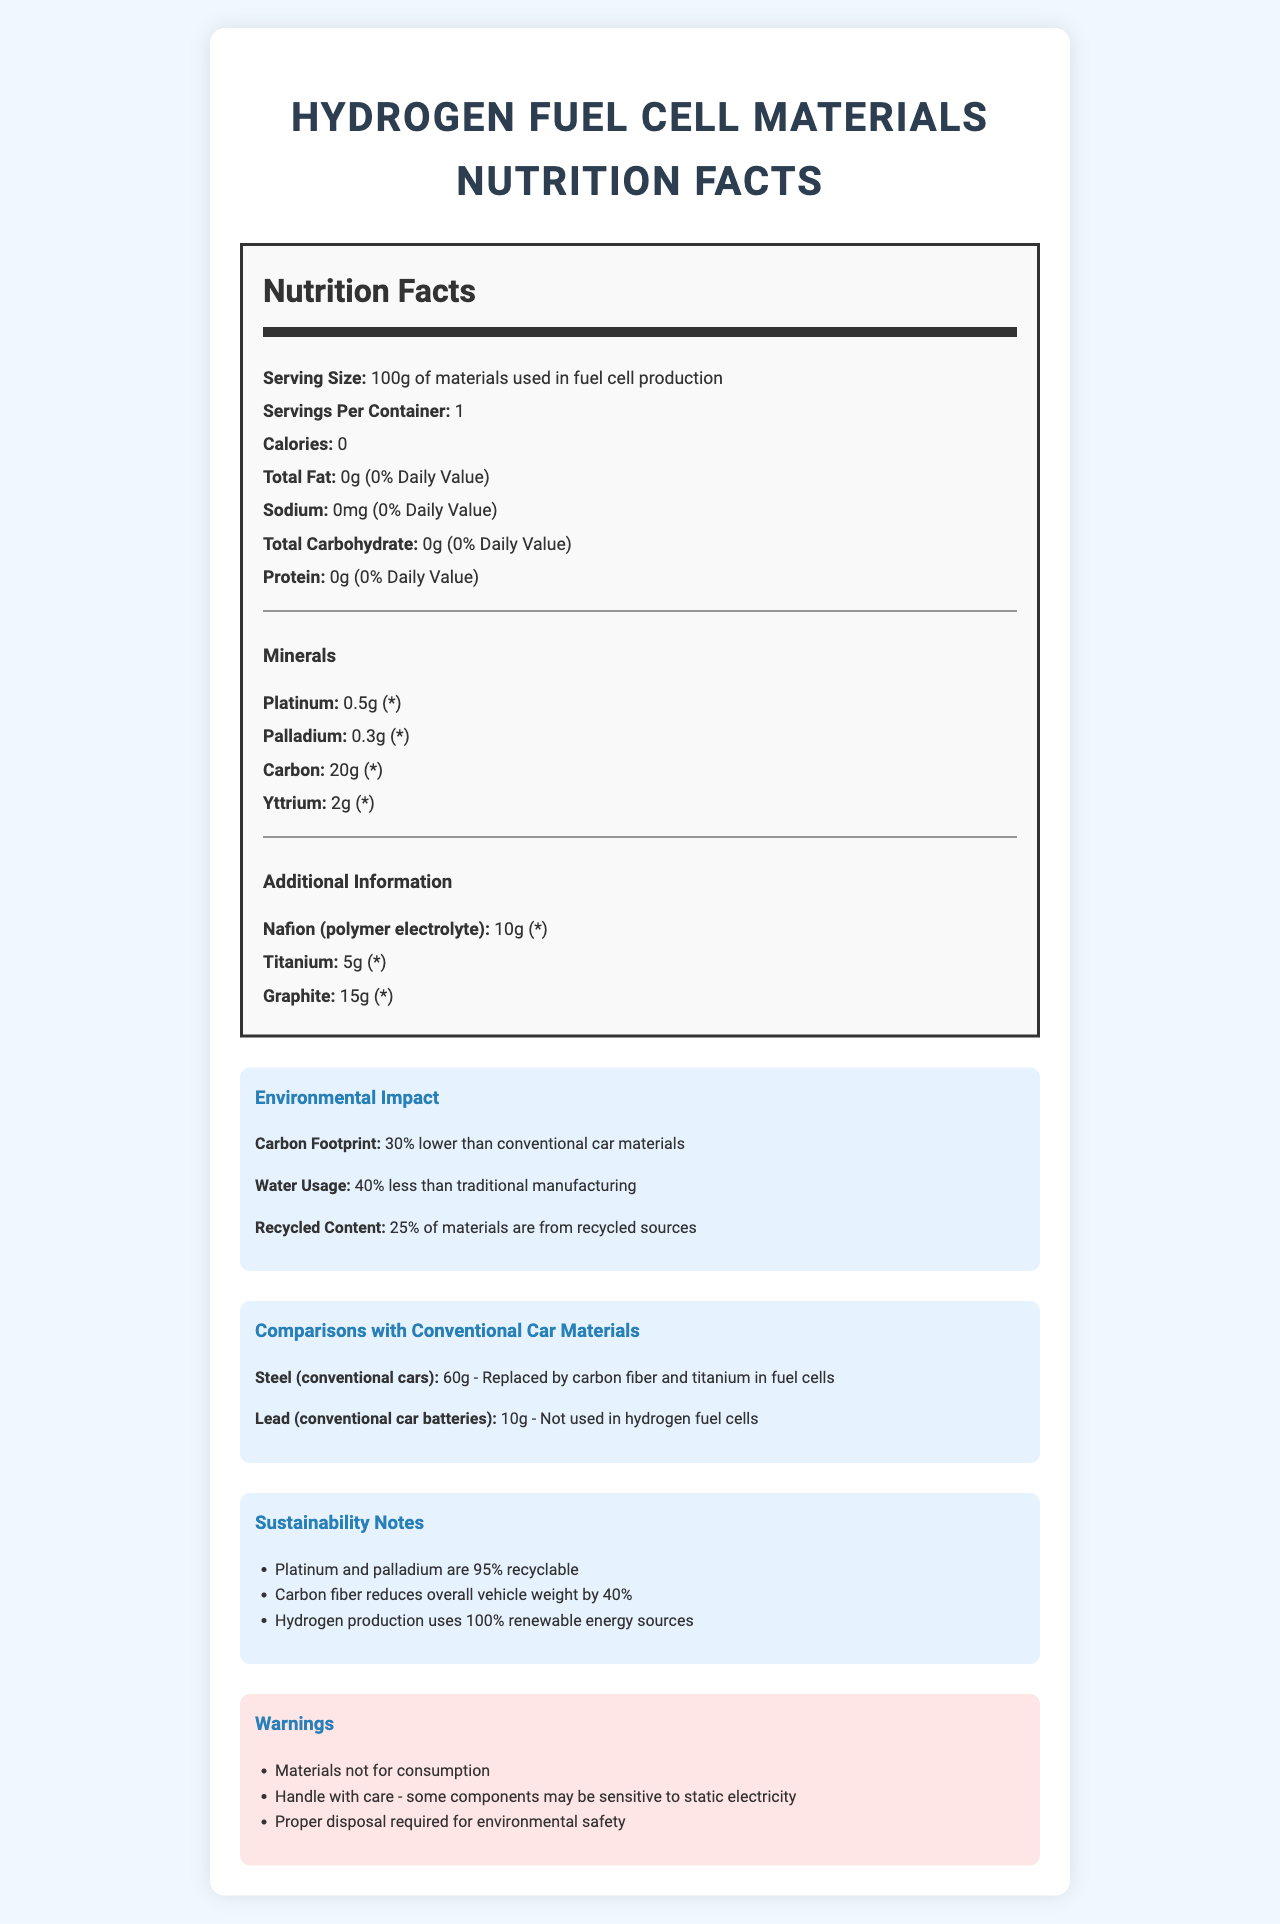what is the serving size described in the document? The serving size is explicitly stated as "100g of materials used in fuel cell production".
Answer: 100g of materials used in fuel cell production How much carbon is used per serving? The document lists Carbon under the minerals with an amount of 20g.
Answer: 20g How much sodium is present in the materials used for fuel cell production? The document clearly states that the sodium content is 0mg.
Answer: 0mg What is the percent daily value of total fat in the listed materials? The document specifies that the total fat amount is 0g, which constitutes 0% daily value.
Answer: 0% What are two minerals listed in the nutrition facts with their amounts? The document lists Platinum with an amount of 0.5g and Palladium with an amount of 0.3g under minerals.
Answer: Platinum: 0.5g, Palladium: 0.3g How much lower is the carbon footprint of hydrogen fuel cell materials compared to conventional car materials? A. 10% B. 20% C. 30% D. 40% The document mentions that the carbon footprint is 30% lower than conventional car materials.
Answer: C. 30% What percent of the materials used in hydrogen fuel cell production come from recycled sources? A. 10% B. 15% C. 25% D. 50% The document states that 25% of the materials are from recycled sources.
Answer: C. 25% Are hydrogen fuel cells better in terms of water usage compared to traditional manufacturing? Yes/No The document specifies that the water usage is 40% less than traditional manufacturing.
Answer: Yes How is the weight of the vehicle affected by the use of carbon fiber in hydrogen fuel cells? Under sustainability notes, the document mentions that carbon fiber reduces overall vehicle weight by 40%.
Answer: It reduces overall vehicle weight by 40% What materials are replaced in hydrogen fuel cells compared to conventional cars? The document states that steel is replaced by carbon fiber and titanium, and lead is not used at all in hydrogen fuel cells.
Answer: Steel and lead Can the daily value percent for sodium in these materials be different from 0%? The document explicitly lists the sodium amount as 0mg and hence the percent daily value as 0%.
Answer: No Why is it necessary to handle some components with care? The document includes a warning about handling with care due to possible sensitivity to static electricity.
Answer: Some components may be sensitive to static electricity What are the correct disposal requirements mentioned in the document? The document states this in the warnings section.
Answer: Proper disposal required for environmental safety Summarize the main focus of this Nutrition Facts Label. This summary encompasses the document's content about composition, environmental impact, sustainability, and safety notes regarding hydrogen fuel cell materials in a comprehensive manner.
Answer: The document provides a detailed nutrition facts label for materials used in hydrogen fuel cell production, highlighting the amounts of various materials, their environmental impact, and comparisons to conventional car manufacturing materials. Additionally, it includes sustainability notes and warnings for handling and disposal. Is the daily value percentage for platinum listed in the document? The document lists platinum amount as 0.5g but does not give a specific daily value percentage, indicated by an asterisk (*).
Answer: Not enough information 